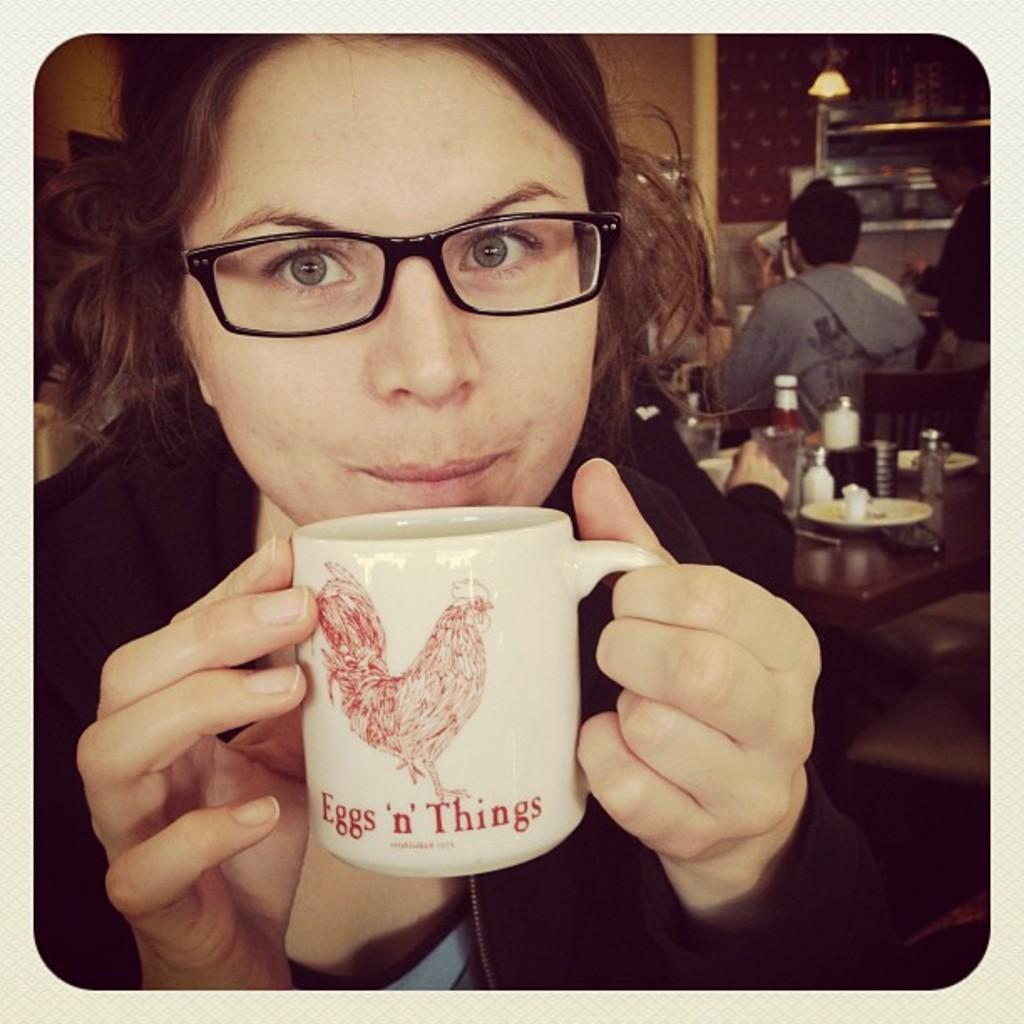What does the mug say?
Your answer should be very brief. Eggs 'n' things. 